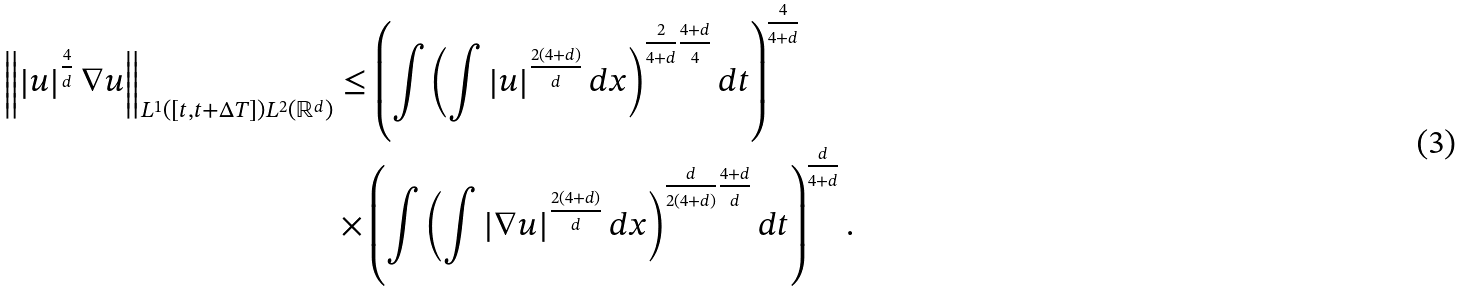<formula> <loc_0><loc_0><loc_500><loc_500>\left \| \left | u \right | ^ { \frac { 4 } { d } } \nabla u \right \| _ { { L ^ { 1 } ( [ t , t + \Delta T ] ) } L ^ { 2 } ( \mathbb { R } ^ { d } ) } & \leq \left ( \int \left ( \int \left | u \right | ^ { \frac { 2 ( 4 + d ) } { d } } d x \right ) ^ { \frac { 2 } { 4 + d } \frac { 4 + d } { 4 } } d t \right ) ^ { \frac { 4 } { 4 + d } } \\ & \times \left ( \int \left ( \int \left | \nabla u \right | ^ { \frac { 2 ( 4 + d ) } { d } } d x \right ) ^ { \frac { d } { 2 ( 4 + d ) } \frac { 4 + d } { d } } d t \right ) ^ { \frac { d } { 4 + d } } .</formula> 